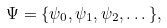Convert formula to latex. <formula><loc_0><loc_0><loc_500><loc_500>\Psi = \{ \psi _ { 0 } , \psi _ { 1 } , \psi _ { 2 } , \dots \} ,</formula> 